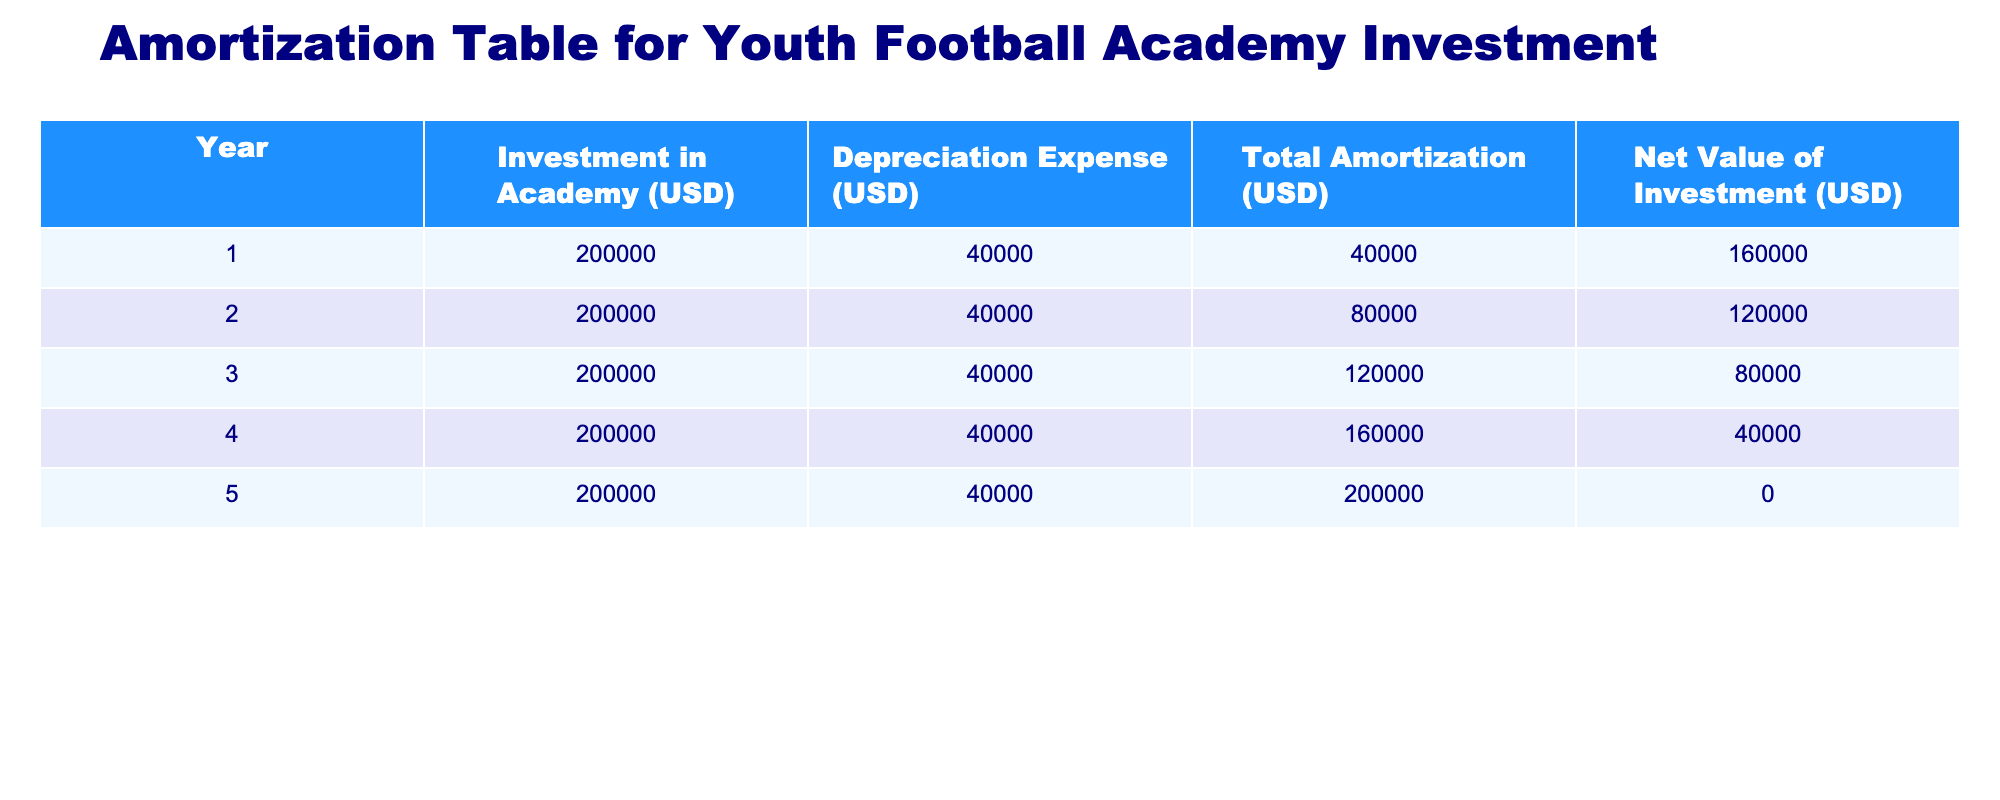What was the total investment in the academy over the 5 years? The investment in the academy is consistently $200,000 per year for 5 years. So, to find the total investment, we multiply the yearly investment by the number of years: 200,000 * 5 = 1,000,000.
Answer: 1,000,000 In which year was the net value of the investment lowest? Looking at the table, the net value of the investment reaches $0 in year 5, which is the lowest value indicated in the last year of investment.
Answer: Year 5 What is the total depreciation expense over the 5 years? Each year, the depreciation expense is $40,000. Therefore, to find the total depreciation expense, multiply the yearly expense by the number of years: 40,000 * 5 = 200,000.
Answer: 200,000 How much is the net value of the investment in year 3? Referring to the table, the net value for year 3 is explicitly stated as $80,000.
Answer: 80,000 Is the total amortization in year 4 greater than in year 2? In year 4, the total amortization is $160,000, while in year 2 it is $80,000. Since 160,000 is more than 80,000, we conclude that the statement is true.
Answer: Yes What is the average depreciation expense per year? The total depreciation expense over 5 years is $200,000 (as calculated before). To find the average, we divide this total by the number of years: 200,000 / 5 = 40,000.
Answer: 40,000 What is the difference between the total amortization in year 1 and year 5? From the table, the total amortization in year 1 is $40,000 and in year 5 it is $200,000. The difference is calculated as 200,000 - 40,000 = 160,000.
Answer: 160,000 In which year did the total amortization double the previous year's amount? Starting from year 1 with an amortization of $40,000, it doubles to $80,000 in year 2, so the change is seen between year 1 and year 2.
Answer: Year 2 Is there any year where the net value of the investment is greater than the total amortization? In year 1, the net value of the investment is $160,000, while the total amortization is $40,000. Thus, 160,000 is greater than 40,000, making this statement true.
Answer: Yes 